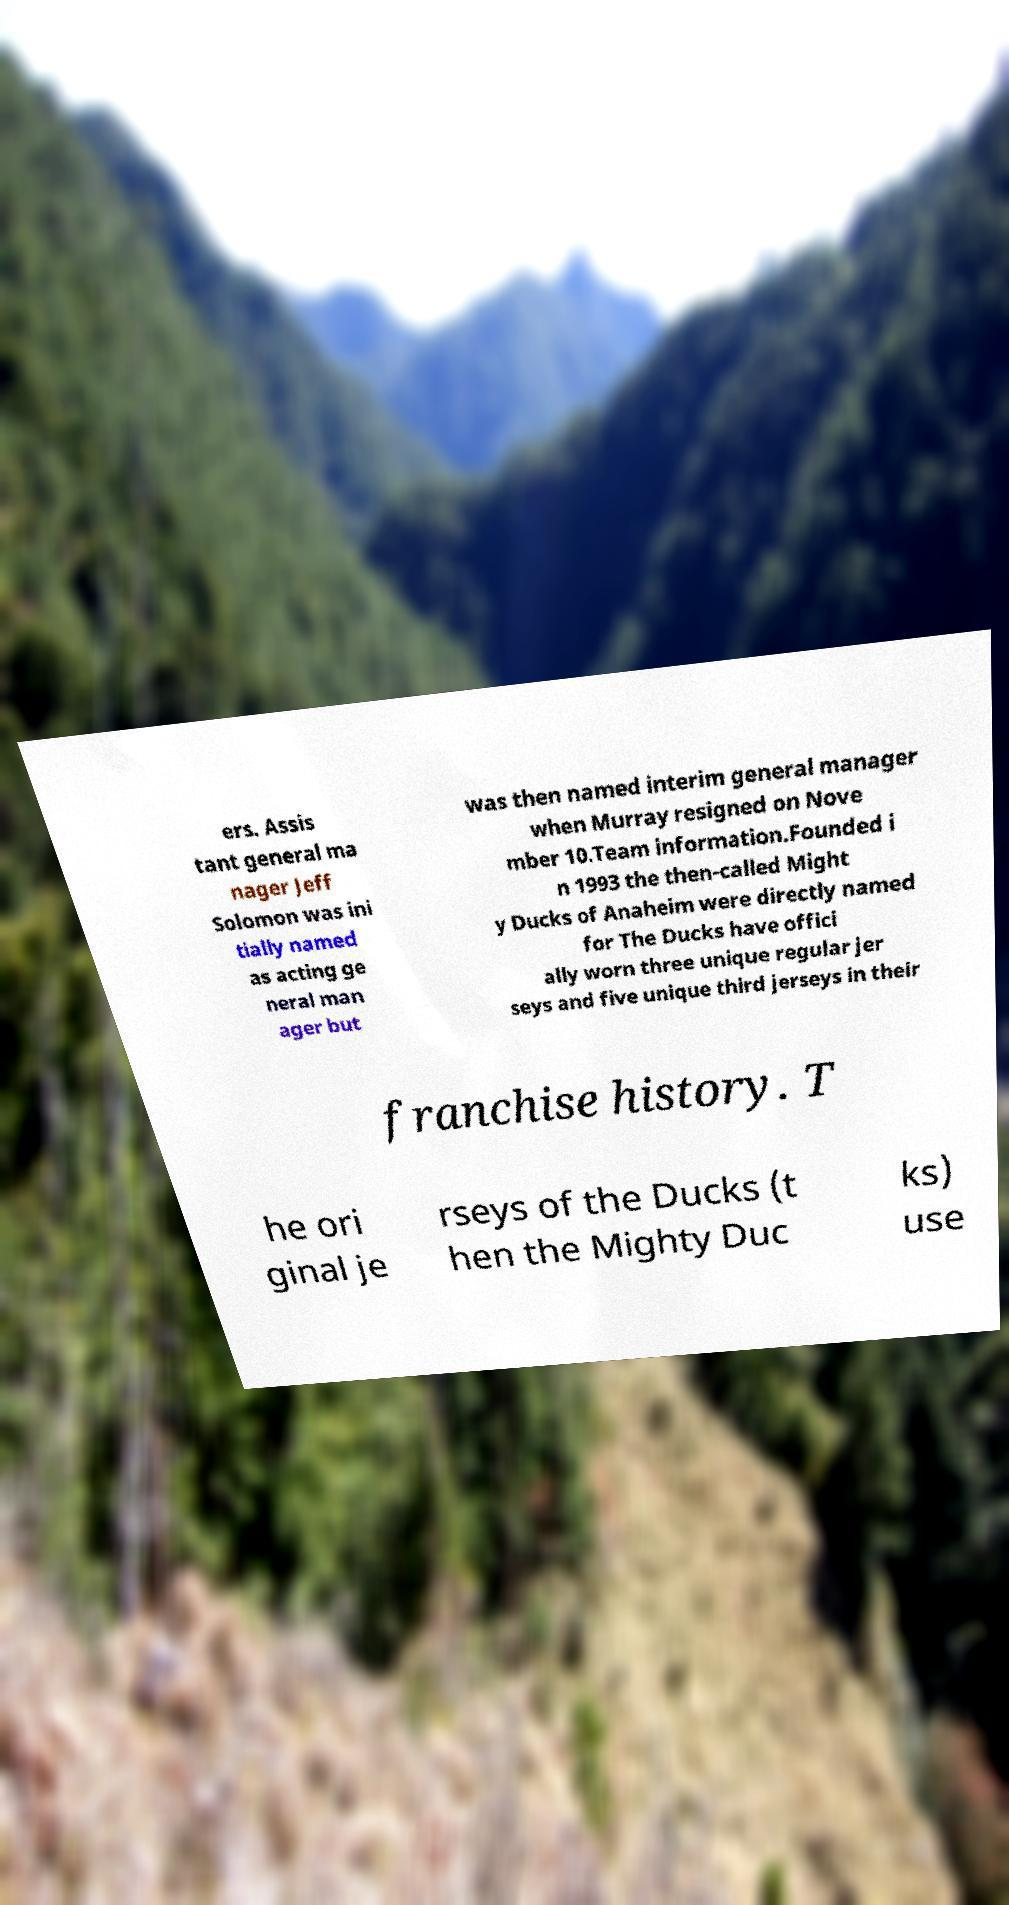Could you assist in decoding the text presented in this image and type it out clearly? ers. Assis tant general ma nager Jeff Solomon was ini tially named as acting ge neral man ager but was then named interim general manager when Murray resigned on Nove mber 10.Team information.Founded i n 1993 the then-called Might y Ducks of Anaheim were directly named for The Ducks have offici ally worn three unique regular jer seys and five unique third jerseys in their franchise history. T he ori ginal je rseys of the Ducks (t hen the Mighty Duc ks) use 